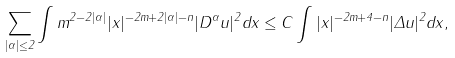Convert formula to latex. <formula><loc_0><loc_0><loc_500><loc_500>\sum _ { | \alpha | \leq 2 } \int m ^ { 2 - 2 | \alpha | } | x | ^ { - 2 m + 2 | \alpha | - n } | D ^ { \alpha } u | ^ { 2 } d x \leq C \int { | x | ^ { - 2 m + 4 - n } | \Delta u | ^ { 2 } d x } ,</formula> 